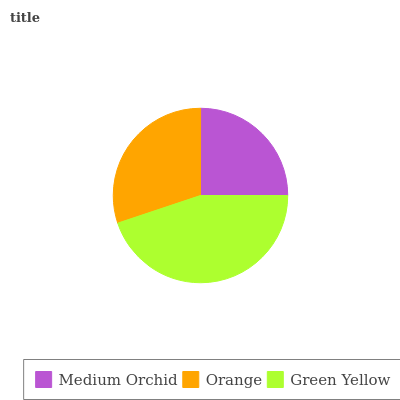Is Medium Orchid the minimum?
Answer yes or no. Yes. Is Green Yellow the maximum?
Answer yes or no. Yes. Is Orange the minimum?
Answer yes or no. No. Is Orange the maximum?
Answer yes or no. No. Is Orange greater than Medium Orchid?
Answer yes or no. Yes. Is Medium Orchid less than Orange?
Answer yes or no. Yes. Is Medium Orchid greater than Orange?
Answer yes or no. No. Is Orange less than Medium Orchid?
Answer yes or no. No. Is Orange the high median?
Answer yes or no. Yes. Is Orange the low median?
Answer yes or no. Yes. Is Green Yellow the high median?
Answer yes or no. No. Is Green Yellow the low median?
Answer yes or no. No. 